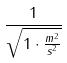<formula> <loc_0><loc_0><loc_500><loc_500>\frac { 1 } { \sqrt { 1 \cdot \frac { m ^ { 2 } } { s ^ { 2 } } } }</formula> 